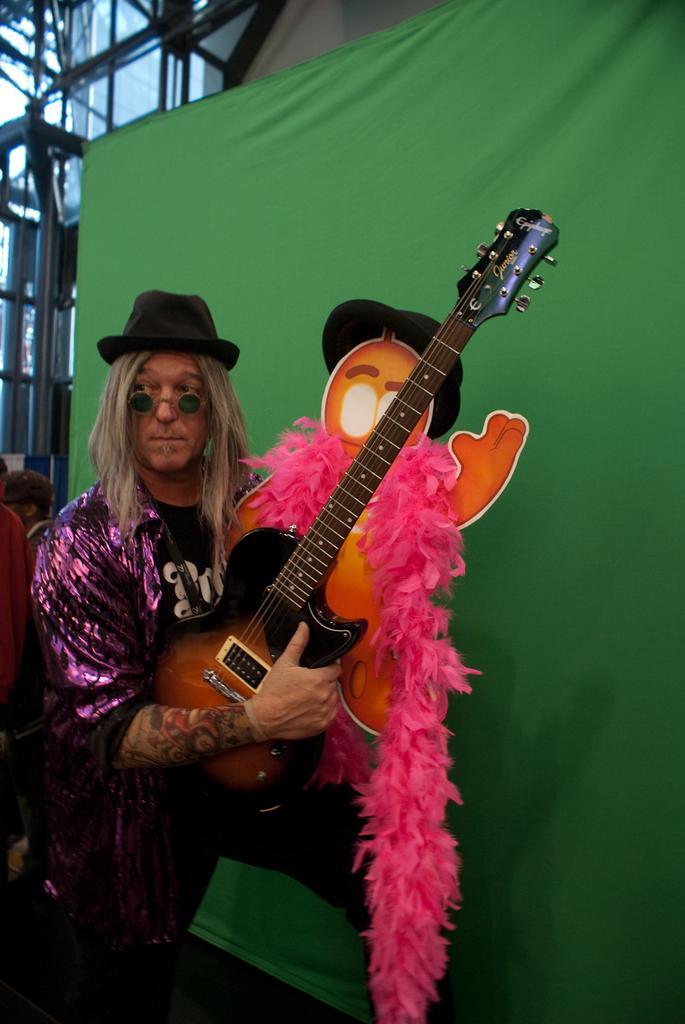In one or two sentences, can you explain what this image depicts? There is a person standing and holding guitar. On the background we can see banner. 